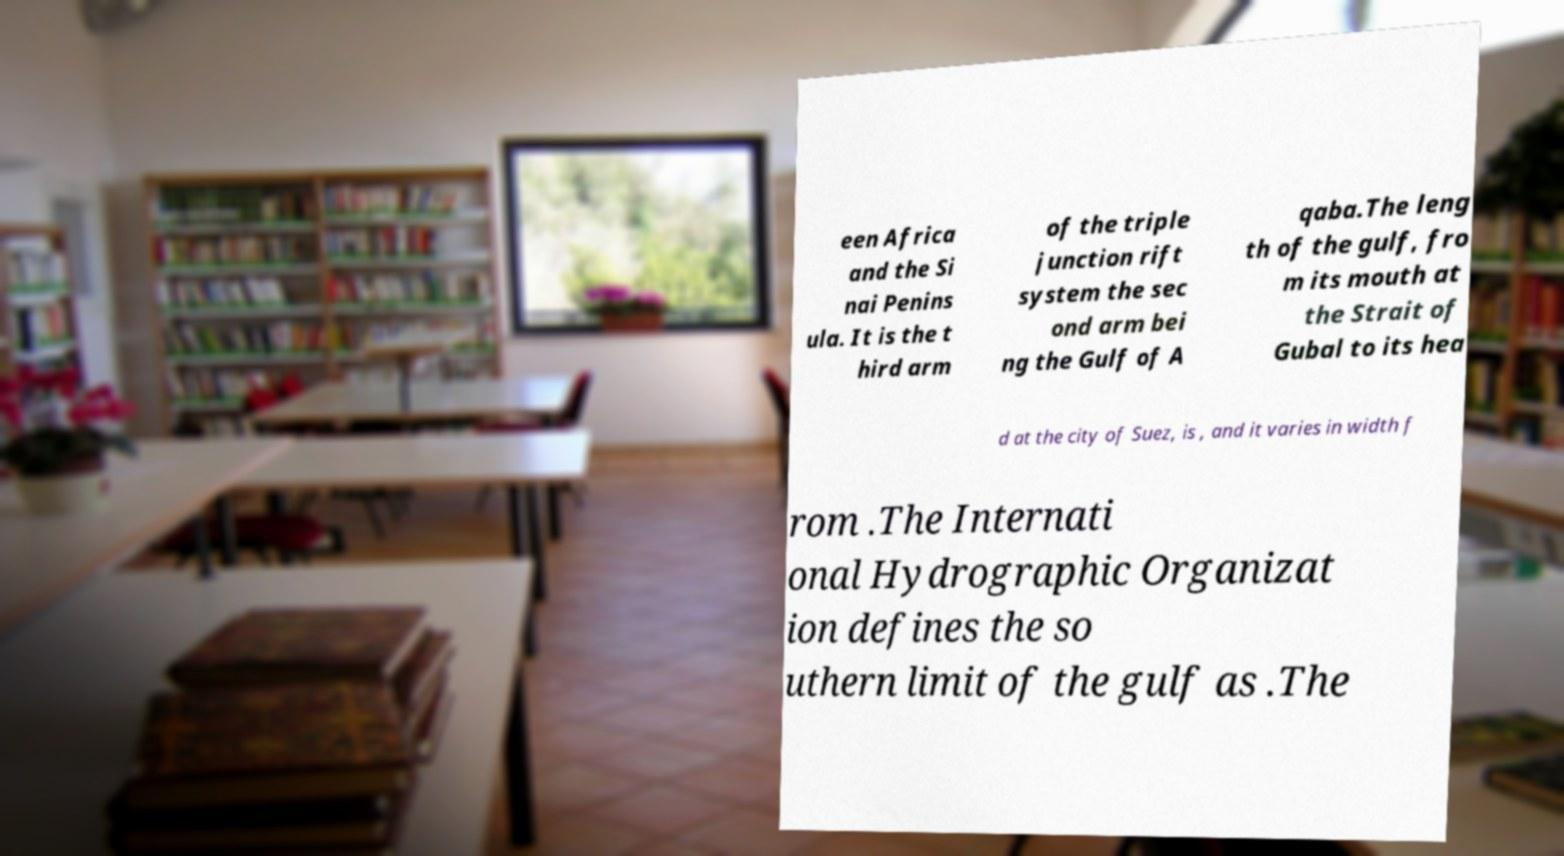I need the written content from this picture converted into text. Can you do that? een Africa and the Si nai Penins ula. It is the t hird arm of the triple junction rift system the sec ond arm bei ng the Gulf of A qaba.The leng th of the gulf, fro m its mouth at the Strait of Gubal to its hea d at the city of Suez, is , and it varies in width f rom .The Internati onal Hydrographic Organizat ion defines the so uthern limit of the gulf as .The 